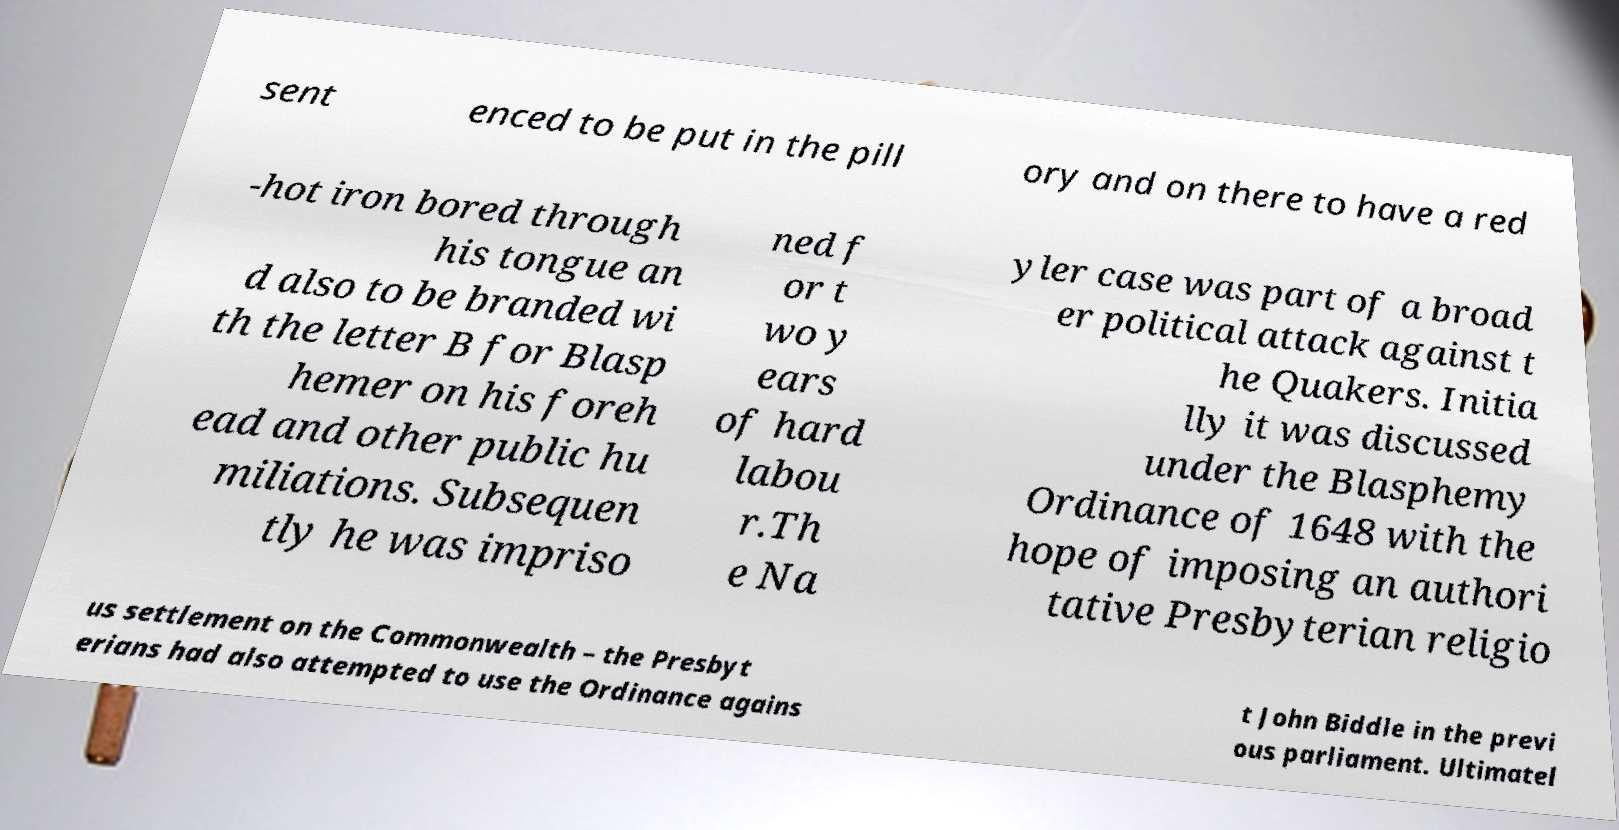Can you accurately transcribe the text from the provided image for me? sent enced to be put in the pill ory and on there to have a red -hot iron bored through his tongue an d also to be branded wi th the letter B for Blasp hemer on his foreh ead and other public hu miliations. Subsequen tly he was impriso ned f or t wo y ears of hard labou r.Th e Na yler case was part of a broad er political attack against t he Quakers. Initia lly it was discussed under the Blasphemy Ordinance of 1648 with the hope of imposing an authori tative Presbyterian religio us settlement on the Commonwealth – the Presbyt erians had also attempted to use the Ordinance agains t John Biddle in the previ ous parliament. Ultimatel 